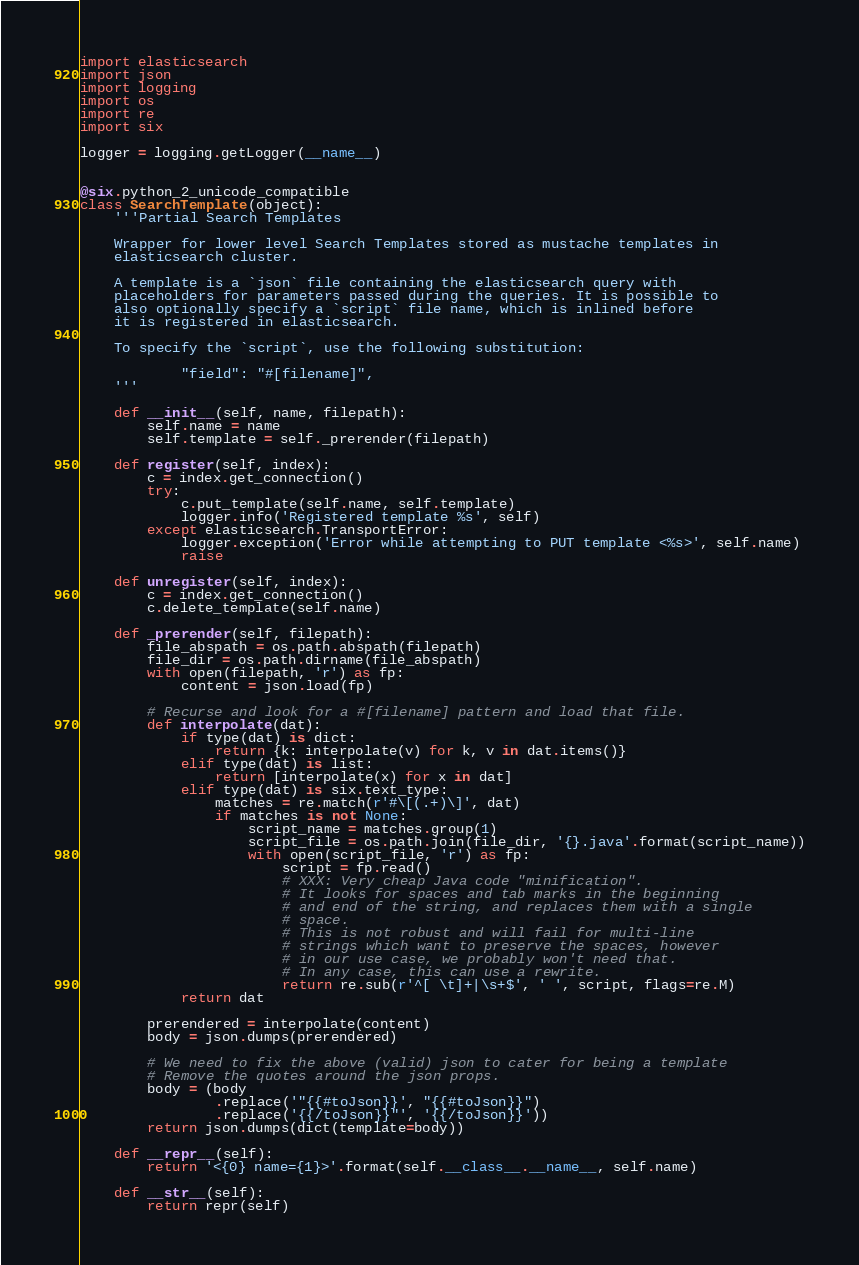<code> <loc_0><loc_0><loc_500><loc_500><_Python_>import elasticsearch
import json
import logging
import os
import re
import six

logger = logging.getLogger(__name__)


@six.python_2_unicode_compatible
class SearchTemplate(object):
    '''Partial Search Templates

    Wrapper for lower level Search Templates stored as mustache templates in
    elasticsearch cluster.

    A template is a `json` file containing the elasticsearch query with
    placeholders for parameters passed during the queries. It is possible to
    also optionally specify a `script` file name, which is inlined before
    it is registered in elasticsearch.

    To specify the `script`, use the following substitution:

            "field": "#[filename]",
    '''

    def __init__(self, name, filepath):
        self.name = name
        self.template = self._prerender(filepath)

    def register(self, index):
        c = index.get_connection()
        try:
            c.put_template(self.name, self.template)
            logger.info('Registered template %s', self)
        except elasticsearch.TransportError:
            logger.exception('Error while attempting to PUT template <%s>', self.name)
            raise

    def unregister(self, index):
        c = index.get_connection()
        c.delete_template(self.name)

    def _prerender(self, filepath):
        file_abspath = os.path.abspath(filepath)
        file_dir = os.path.dirname(file_abspath)
        with open(filepath, 'r') as fp:
            content = json.load(fp)

        # Recurse and look for a #[filename] pattern and load that file.
        def interpolate(dat):
            if type(dat) is dict:
                return {k: interpolate(v) for k, v in dat.items()}
            elif type(dat) is list:
                return [interpolate(x) for x in dat]
            elif type(dat) is six.text_type:
                matches = re.match(r'#\[(.+)\]', dat)
                if matches is not None:
                    script_name = matches.group(1)
                    script_file = os.path.join(file_dir, '{}.java'.format(script_name))
                    with open(script_file, 'r') as fp:
                        script = fp.read()
                        # XXX: Very cheap Java code "minification".
                        # It looks for spaces and tab marks in the beginning
                        # and end of the string, and replaces them with a single
                        # space.
                        # This is not robust and will fail for multi-line
                        # strings which want to preserve the spaces, however
                        # in our use case, we probably won't need that.
                        # In any case, this can use a rewrite.
                        return re.sub(r'^[ \t]+|\s+$', ' ', script, flags=re.M)
            return dat

        prerendered = interpolate(content)
        body = json.dumps(prerendered)

        # We need to fix the above (valid) json to cater for being a template
        # Remove the quotes around the json props.
        body = (body
                .replace('"{{#toJson}}', "{{#toJson}}")
                .replace('{{/toJson}}"', '{{/toJson}}'))
        return json.dumps(dict(template=body))

    def __repr__(self):
        return '<{0} name={1}>'.format(self.__class__.__name__, self.name)

    def __str__(self):
        return repr(self)
</code> 